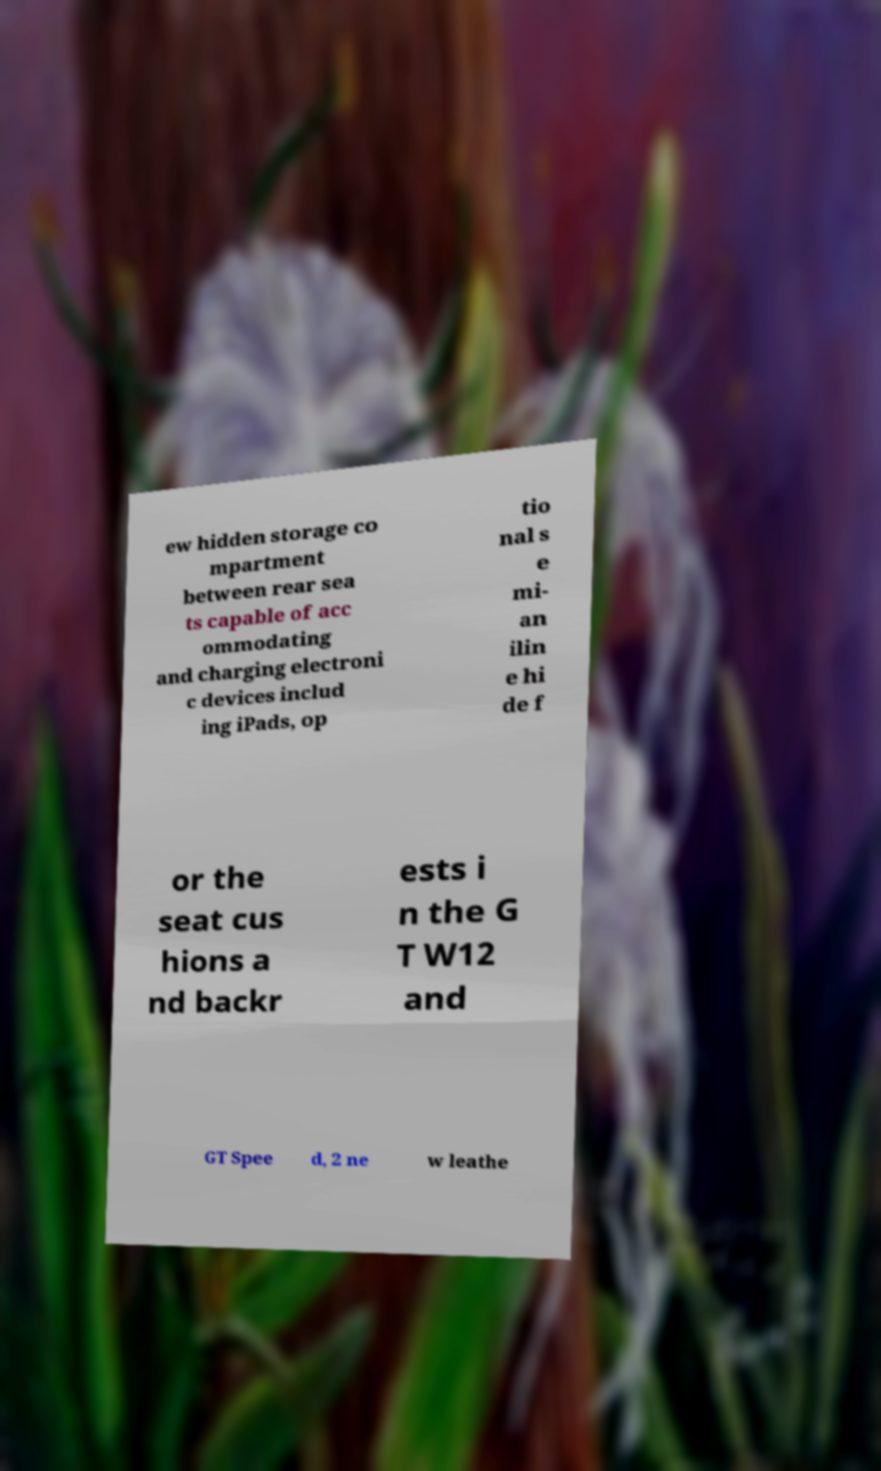What messages or text are displayed in this image? I need them in a readable, typed format. ew hidden storage co mpartment between rear sea ts capable of acc ommodating and charging electroni c devices includ ing iPads, op tio nal s e mi- an ilin e hi de f or the seat cus hions a nd backr ests i n the G T W12 and GT Spee d, 2 ne w leathe 